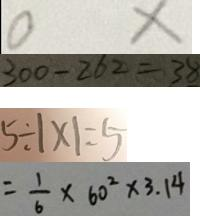Convert formula to latex. <formula><loc_0><loc_0><loc_500><loc_500>0 x 
 3 0 0 - 2 6 2 = 3 8 
 5 \div 1 \times 1 = 5 
 = \frac { 1 } { 6 } \times 6 0 ^ { 2 } \times 3 . 1 4</formula> 